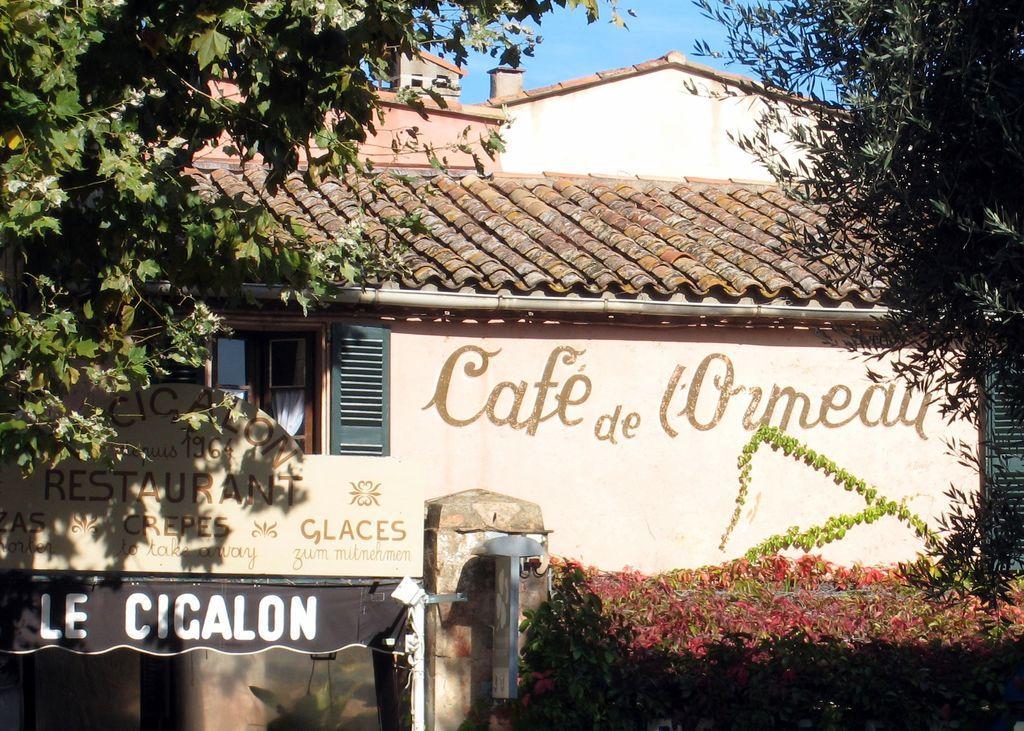In one or two sentences, can you explain what this image depicts? In this image we can see one house, some text on the house wall, one window with a white curtain, one glass door, some trees, some plants on the surface, one board attached to the wall, one banner with text, some objects are on the surface and at the top there is the sky. 